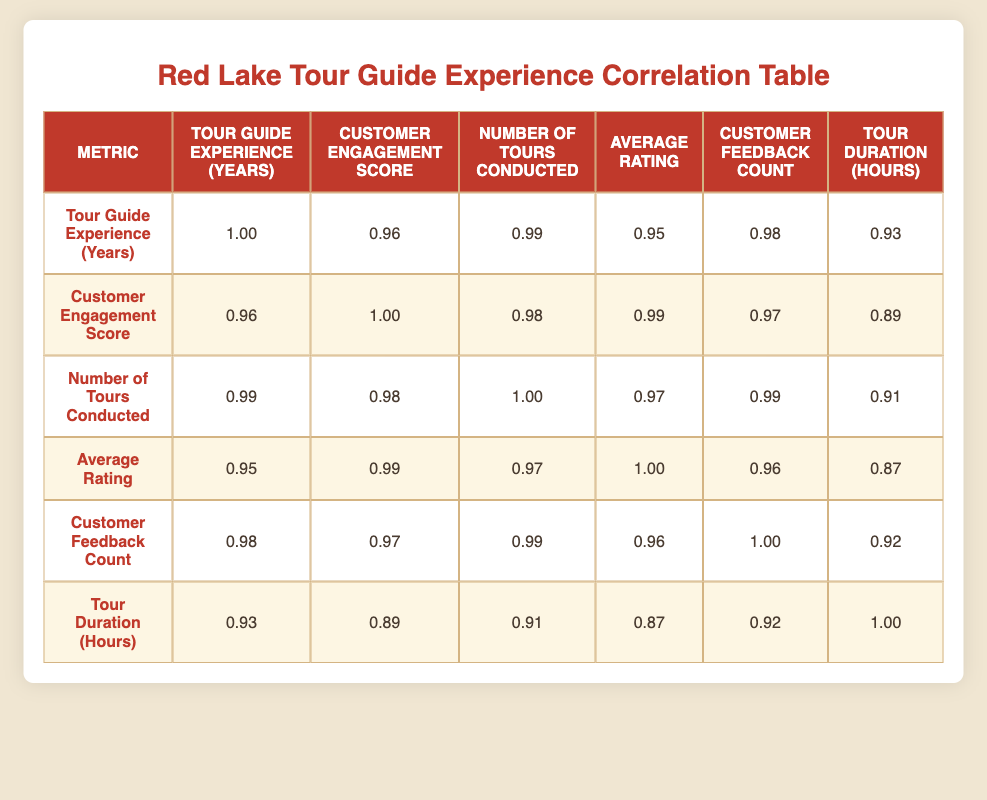What is the correlation between tour guide experience and customer engagement score? The correlation between tour guide experience and customer engagement score is 0.96, which shows a strong positive relationship, indicating that as tour guide experience increases, so does the customer engagement score.
Answer: 0.96 What is the average rating when the number of tours conducted is the highest? The highest value for the number of tours conducted is 200. At this level, the average rating is 5.0, meaning that the average rating is maintained at its maximum when conducting the most tours.
Answer: 5.0 Is there a strong correlation between customer feedback count and tour duration hours? The correlation coefficient between customer feedback count and tour duration hours is 0.92, which indicates a strong positive correlation, suggesting that an increase in customer feedback is associated with longer tour durations.
Answer: Yes What is the correlation between the average rating and customer engagement scores? The correlation between the average rating and customer engagement score is 0.99, indicating a very strong positive relationship, which suggests that higher average ratings are closely linked to higher customer engagement scores.
Answer: 0.99 What is the total number of tours conducted for the experience level of 15 years? For the experience level of 15 years, the number of tours conducted is 150, representing the total tours after accumulating that level of experience.
Answer: 150 How does the customer engagement score change when tour guide experience increases from 5 years to 10 years? The customer engagement score for 5 years of experience is 80, and for 10 years, it is 90. The change is 90 - 80 = 10, indicating that the score increases by 10 when experience increases by 5 years.
Answer: 10 What is the relationship between the number of tours conducted and the average rating? The correlation coefficient between the number of tours conducted and average rating is 0.97, indicating a strong positive correlation, meaning that more tours conducted is likely to result in higher average ratings from customers.
Answer: 0.97 Does a longer tour duration correlate negatively with customer engagement scores? The correlation between tour duration hours and customer engagement score is 0.89, which shows a positive correlation rather than a negative one, meaning longer tours are associated with higher customer engagement scores.
Answer: No How much does the customer feedback count increase from 5 years of experience to 10 years? For 5 years of experience, the customer feedback count is 80, and at 10 years it is 150, which results in an increase of 150 - 80 = 70. This indicates that feedback significantly increases alongside experience.
Answer: 70 